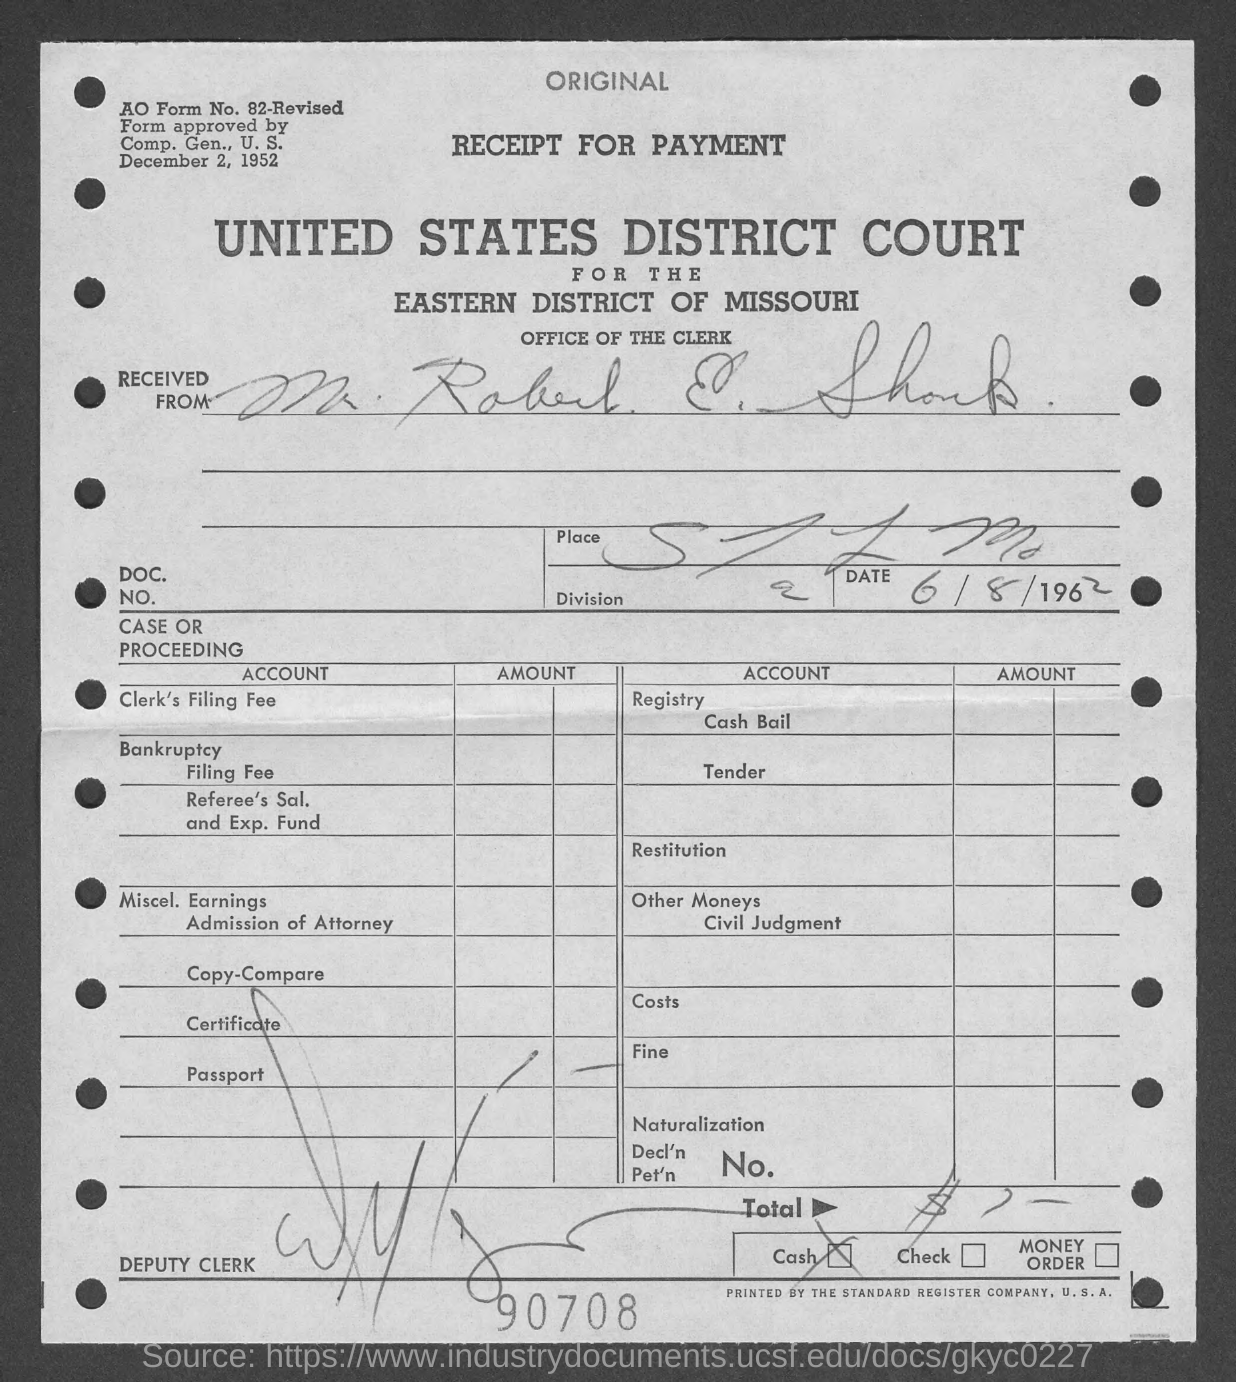Indicate a few pertinent items in this graphic. I would like to know the number located at the bottom of the page, specifically 90708.... 